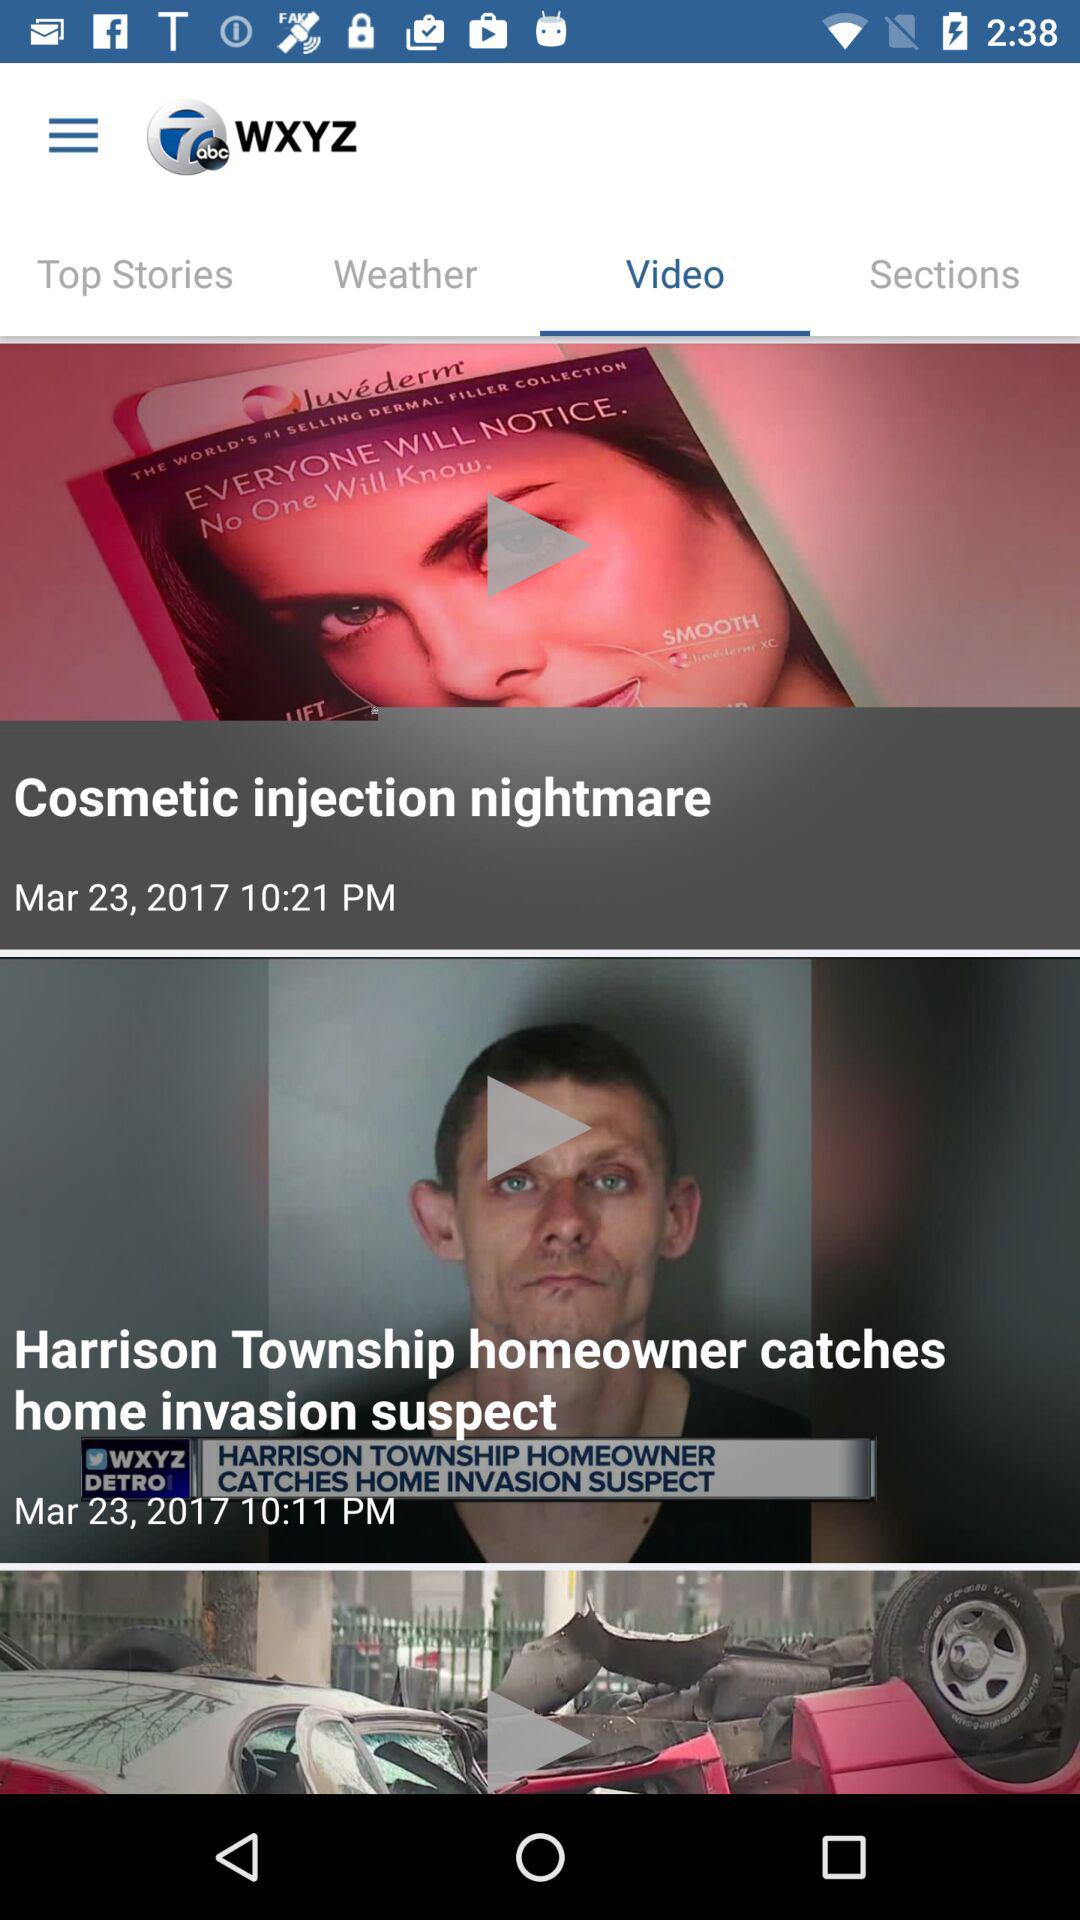What is the name of the application? The name of the application is "WXYZ". 